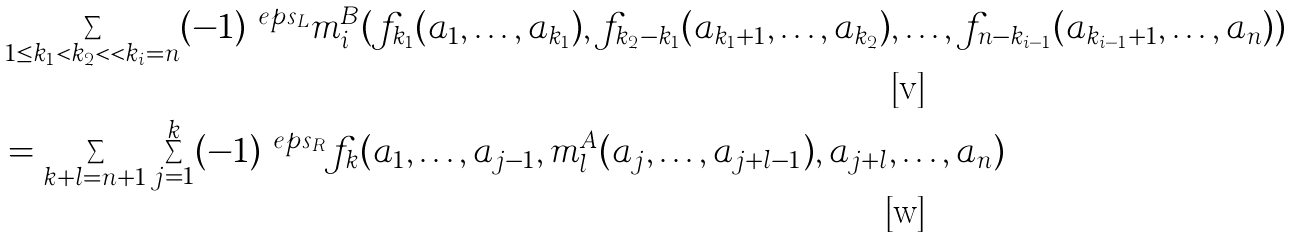Convert formula to latex. <formula><loc_0><loc_0><loc_500><loc_500>& \sum _ { 1 \leq k _ { 1 } < k _ { 2 } < \dots < k _ { i } = n } ( - 1 ) ^ { \ e p s _ { L } } m _ { i } ^ { B } ( f _ { k _ { 1 } } ( a _ { 1 } , \dots , a _ { k _ { 1 } } ) , f _ { k _ { 2 } - k _ { 1 } } ( a _ { k _ { 1 } + 1 } , \dots , a _ { k _ { 2 } } ) , \dots , f _ { n - k _ { i - 1 } } ( a _ { k _ { i - 1 } + 1 } , \dots , a _ { n } ) ) \\ & = \sum _ { k + l = n + 1 } \sum _ { j = 1 } ^ { k } ( - 1 ) ^ { \ e p s _ { R } } f _ { k } ( a _ { 1 } , \dots , a _ { j - 1 } , m _ { l } ^ { A } ( a _ { j } , \dots , a _ { j + l - 1 } ) , a _ { j + l } , \dots , a _ { n } )</formula> 